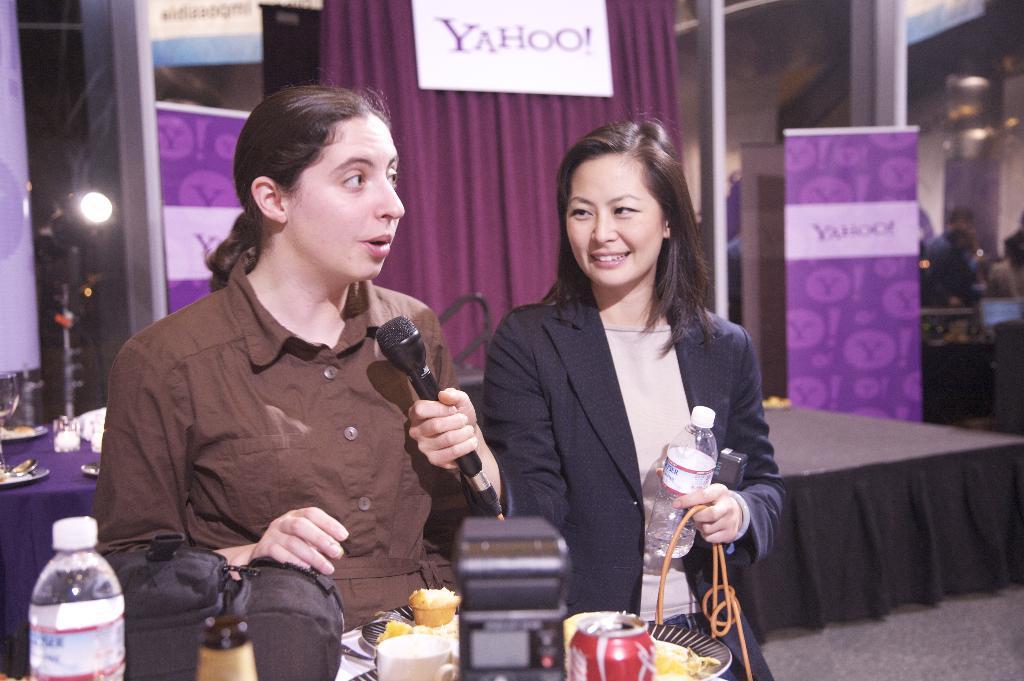Describe this image in one or two sentences. This picture there are two women standing. One Woman at the right side is holding a bottle and wire with one hand and mike with the other hand. Before them there is a bottle, bag, cup, coke can , plate having some food. At the back of them there is a curtain and name plate written with the text as yahoo. At left side there is a light stand and a table having plates , spoons and glasses. At the right side there are few people 